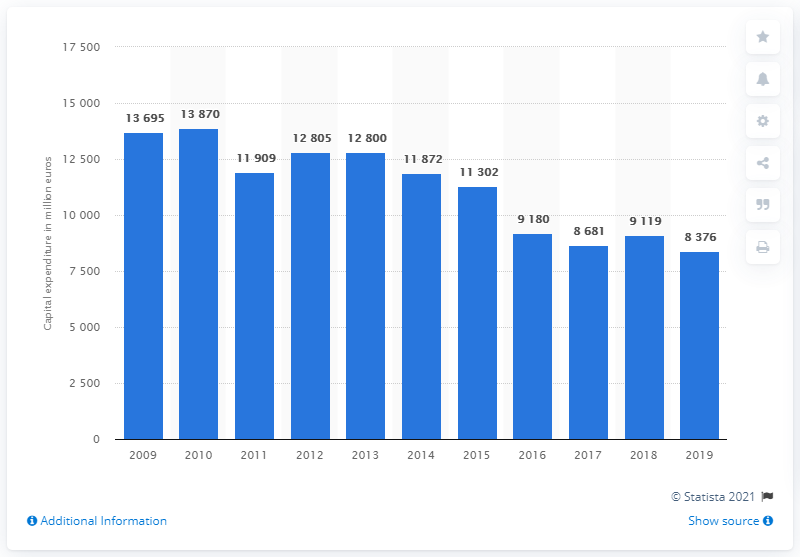Highlight a few significant elements in this photo. Eni S.p.A. reported a capital expenditure of approximately 8,376 in 2019. 